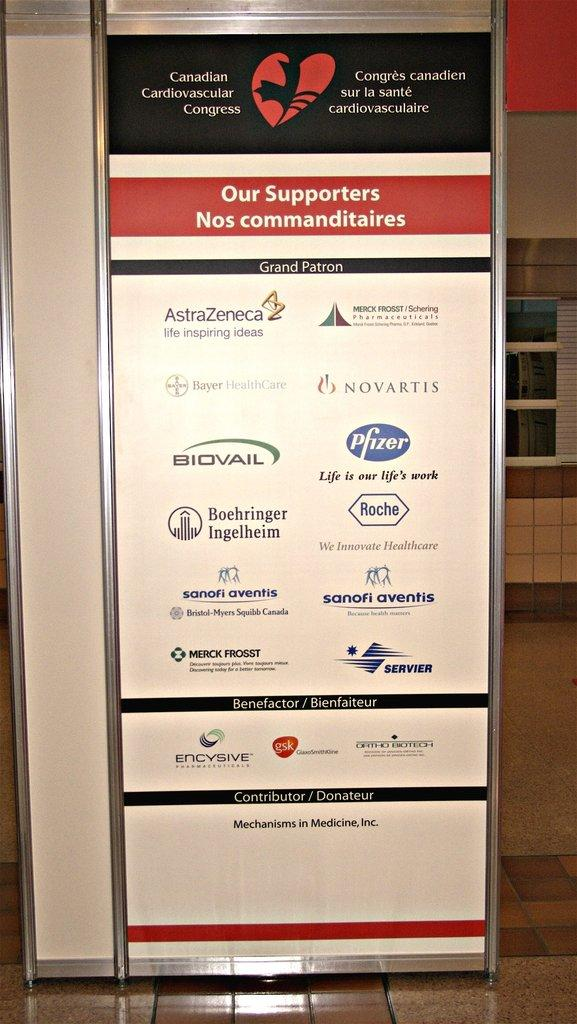What is placed on the floor in the image? There is a board on the floor. What can be seen in the background of the image? There is a wall and glass in the background of the image. What is the hourly income of the women in the image? There are no women present in the image, and therefore no information about their income can be determined. 